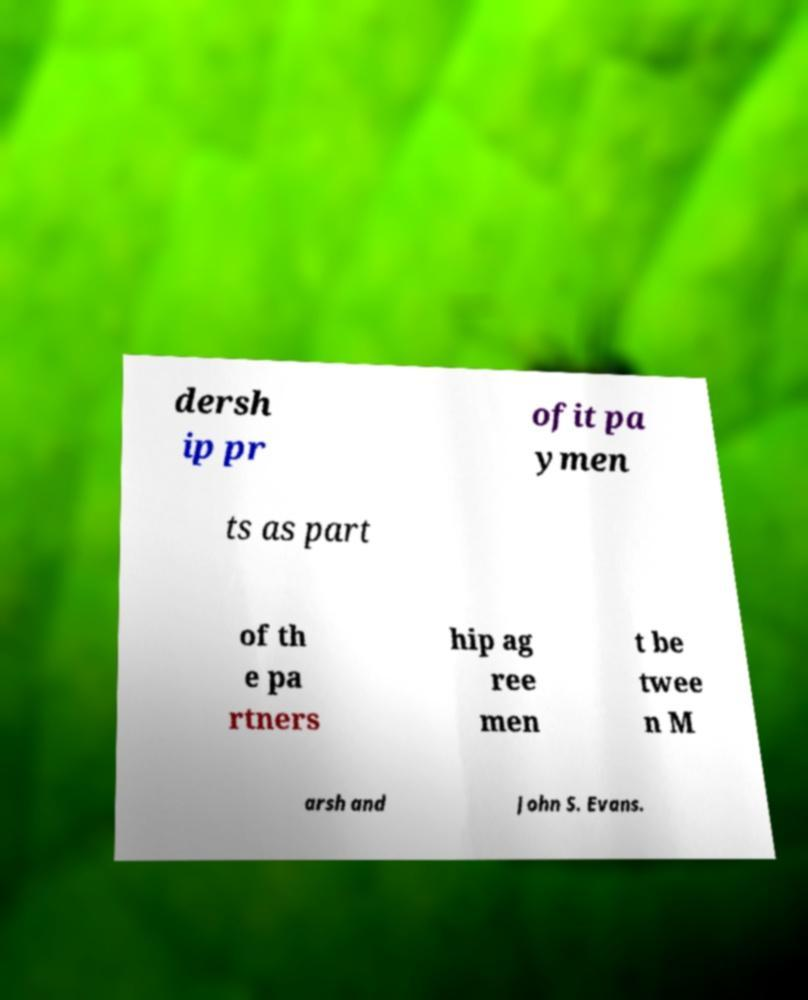There's text embedded in this image that I need extracted. Can you transcribe it verbatim? dersh ip pr ofit pa ymen ts as part of th e pa rtners hip ag ree men t be twee n M arsh and John S. Evans. 